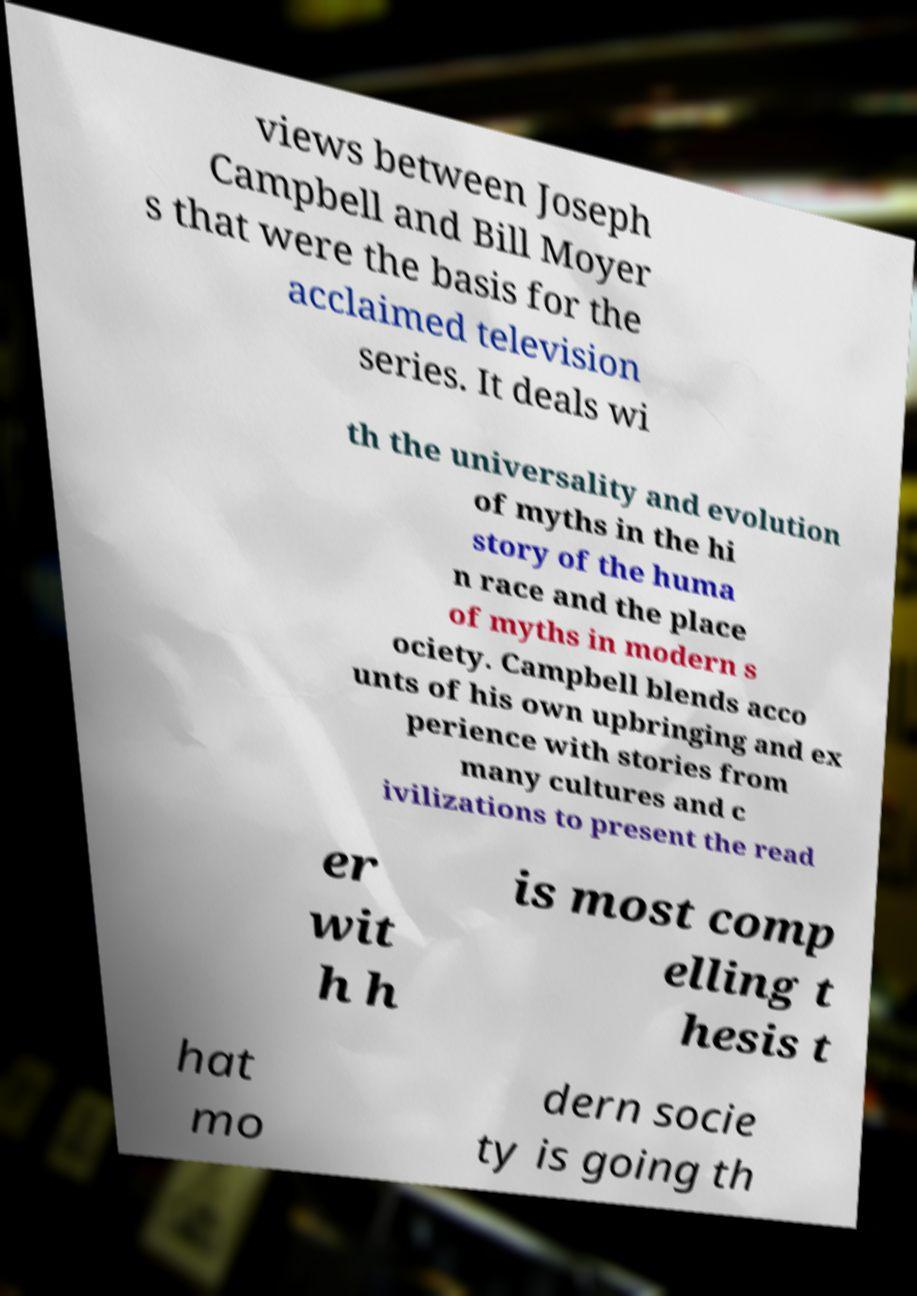Can you accurately transcribe the text from the provided image for me? views between Joseph Campbell and Bill Moyer s that were the basis for the acclaimed television series. It deals wi th the universality and evolution of myths in the hi story of the huma n race and the place of myths in modern s ociety. Campbell blends acco unts of his own upbringing and ex perience with stories from many cultures and c ivilizations to present the read er wit h h is most comp elling t hesis t hat mo dern socie ty is going th 